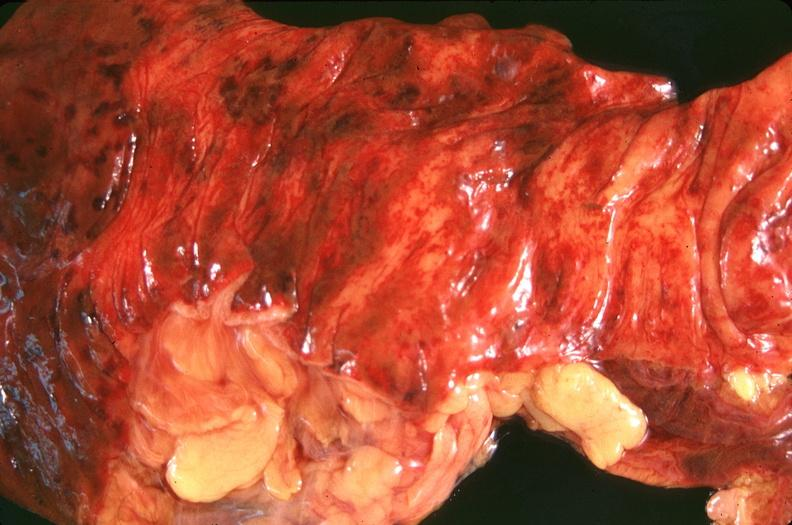s gastrointestinal present?
Answer the question using a single word or phrase. Yes 